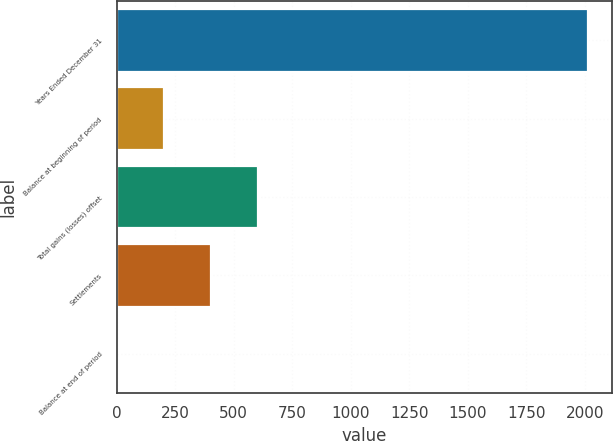Convert chart to OTSL. <chart><loc_0><loc_0><loc_500><loc_500><bar_chart><fcel>Years Ended December 31<fcel>Balance at beginning of period<fcel>Total gains (losses) offset<fcel>Settlements<fcel>Balance at end of period<nl><fcel>2014<fcel>202.3<fcel>604.9<fcel>403.6<fcel>1<nl></chart> 